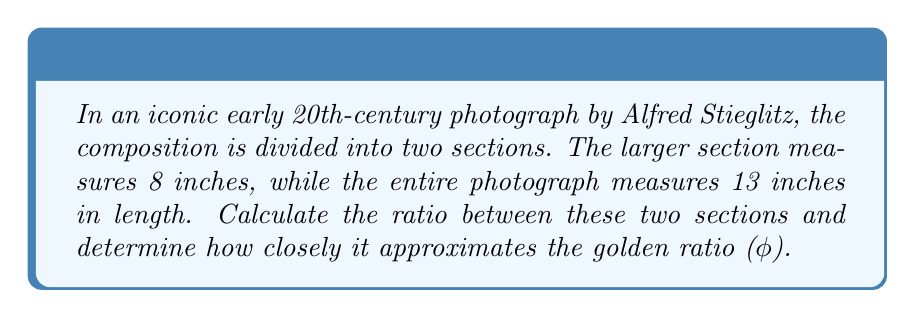Solve this math problem. To solve this problem, we'll follow these steps:

1) First, let's recall that the golden ratio (φ) is approximately 1.618034.

2) In the photograph, we have:
   - Total length: 13 inches
   - Larger section: 8 inches
   - Smaller section: 13 - 8 = 5 inches

3) The ratio we need to calculate is:
   $$\frac{\text{Larger section}}{\text{Smaller section}} = \frac{8}{5} = 1.6$$

4) To compare this to the golden ratio, we can calculate the percentage difference:

   $$\text{Percentage Difference} = \left|\frac{\text{Calculated Ratio} - \text{Golden Ratio}}{\text{Golden Ratio}}\right| \times 100\%$$

   $$= \left|\frac{1.6 - 1.618034}{1.618034}\right| \times 100\%$$
   
   $$\approx 1.11\%$$

5) This means the composition's ratio is very close to the golden ratio, differing by only about 1.11%.
Answer: 1.6 (98.89% accurate to φ) 